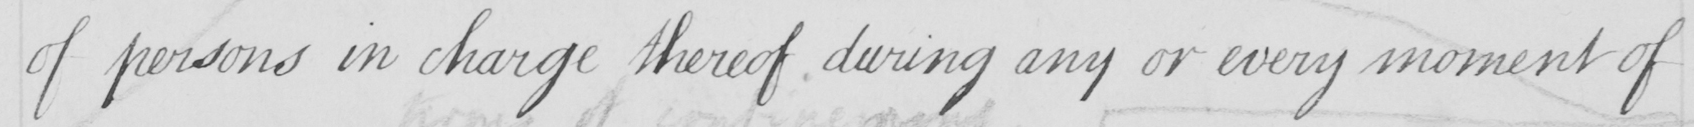Can you read and transcribe this handwriting? of persons in charge thereof during any or every moment of 